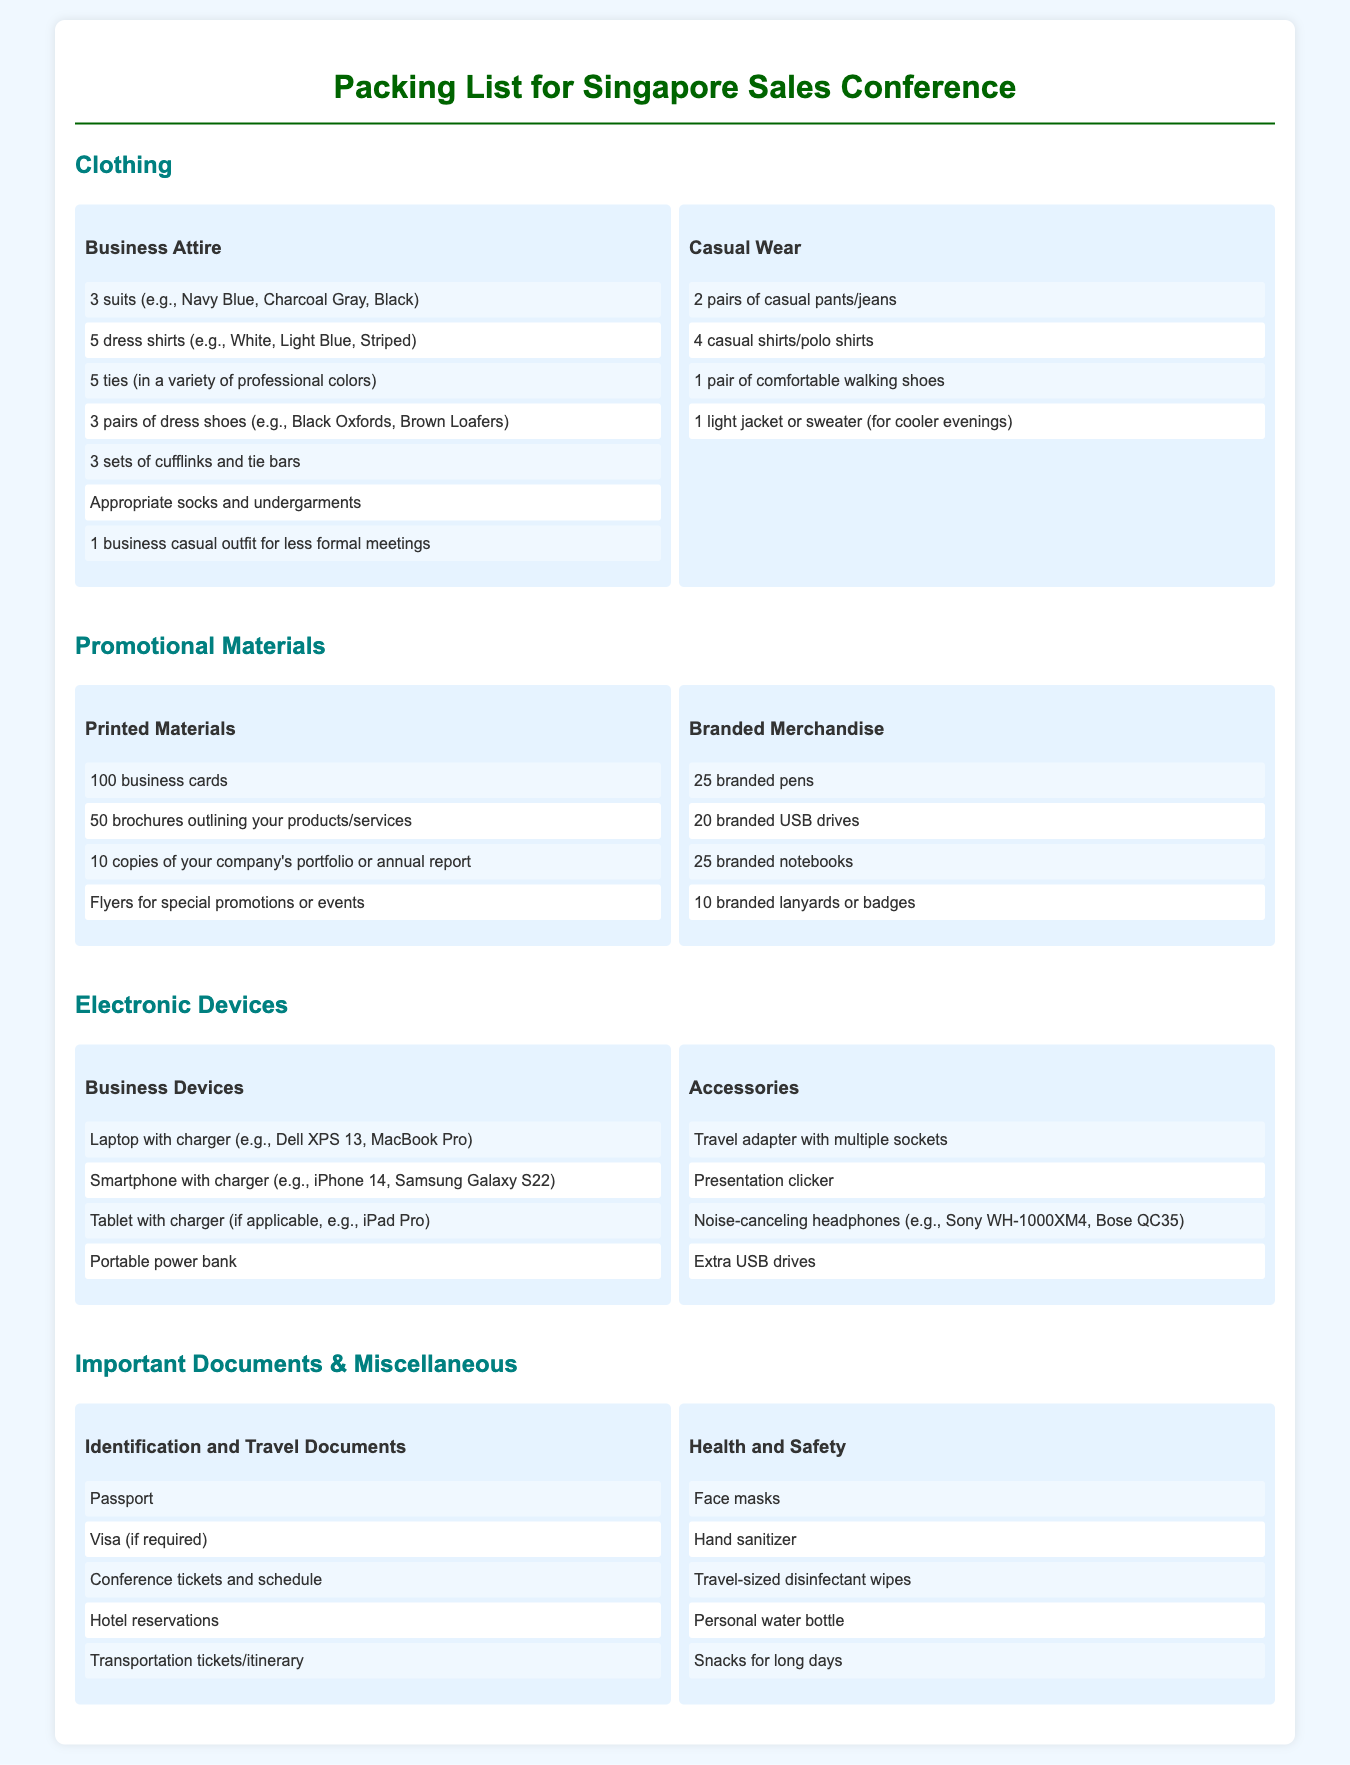What items are included in business attire? The business attire section includes items such as suits, dress shirts, ties, dress shoes, cufflinks, and undergarments.
Answer: 3 suits, 5 dress shirts, 5 ties, 3 pairs of dress shoes, 3 sets of cufflinks and tie bars, appropriate socks and undergarments, 1 business casual outfit How many promotional brochures should I bring? The document specifies that you should bring 50 brochures outlining your products/services for promotional purposes.
Answer: 50 brochures What electronic devices are listed under business devices? The listed items under business devices include a laptop, smartphone, tablet, and a portable power bank.
Answer: Laptop, Smartphone, Tablet, Portable power bank How many branded pens are included in the branded merchandise? The document states that you should bring 25 branded pens as part of your promotional materials.
Answer: 25 branded pens What is included in the health and safety section? The health and safety section includes items such as face masks, hand sanitizer, disinfectant wipes, a personal water bottle, and snacks.
Answer: Face masks, Hand sanitizer, Travel-sized disinfectant wipes, Personal water bottle, Snacks for long days How many dress shirts are on the packing list? The packing list specifies bringing 5 dress shirts in various colors.
Answer: 5 dress shirts 